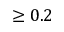<formula> <loc_0><loc_0><loc_500><loc_500>\geq 0 . 2</formula> 